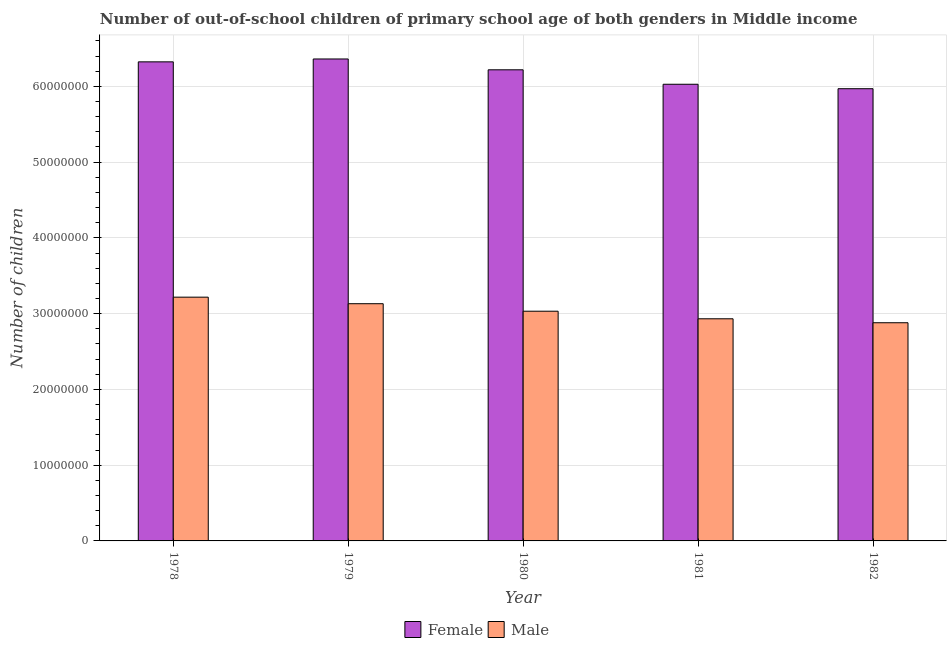How many groups of bars are there?
Your response must be concise. 5. Are the number of bars on each tick of the X-axis equal?
Your answer should be compact. Yes. How many bars are there on the 2nd tick from the left?
Make the answer very short. 2. How many bars are there on the 4th tick from the right?
Make the answer very short. 2. What is the label of the 3rd group of bars from the left?
Your answer should be very brief. 1980. What is the number of male out-of-school students in 1979?
Provide a succinct answer. 3.13e+07. Across all years, what is the maximum number of male out-of-school students?
Ensure brevity in your answer.  3.22e+07. Across all years, what is the minimum number of female out-of-school students?
Provide a succinct answer. 5.97e+07. In which year was the number of male out-of-school students maximum?
Ensure brevity in your answer.  1978. In which year was the number of female out-of-school students minimum?
Make the answer very short. 1982. What is the total number of female out-of-school students in the graph?
Provide a succinct answer. 3.09e+08. What is the difference between the number of female out-of-school students in 1979 and that in 1981?
Your answer should be compact. 3.34e+06. What is the difference between the number of male out-of-school students in 1982 and the number of female out-of-school students in 1979?
Your response must be concise. -2.51e+06. What is the average number of female out-of-school students per year?
Provide a succinct answer. 6.18e+07. In how many years, is the number of female out-of-school students greater than 34000000?
Provide a short and direct response. 5. What is the ratio of the number of female out-of-school students in 1979 to that in 1981?
Your answer should be very brief. 1.06. Is the number of male out-of-school students in 1981 less than that in 1982?
Ensure brevity in your answer.  No. Is the difference between the number of female out-of-school students in 1978 and 1982 greater than the difference between the number of male out-of-school students in 1978 and 1982?
Your response must be concise. No. What is the difference between the highest and the second highest number of female out-of-school students?
Provide a succinct answer. 3.79e+05. What is the difference between the highest and the lowest number of male out-of-school students?
Your answer should be very brief. 3.38e+06. In how many years, is the number of male out-of-school students greater than the average number of male out-of-school students taken over all years?
Ensure brevity in your answer.  2. What does the 2nd bar from the left in 1981 represents?
Keep it short and to the point. Male. What does the 2nd bar from the right in 1978 represents?
Offer a terse response. Female. How many years are there in the graph?
Your response must be concise. 5. What is the difference between two consecutive major ticks on the Y-axis?
Make the answer very short. 1.00e+07. Are the values on the major ticks of Y-axis written in scientific E-notation?
Offer a terse response. No. Does the graph contain any zero values?
Make the answer very short. No. How many legend labels are there?
Your response must be concise. 2. What is the title of the graph?
Your answer should be compact. Number of out-of-school children of primary school age of both genders in Middle income. Does "Unregistered firms" appear as one of the legend labels in the graph?
Give a very brief answer. No. What is the label or title of the X-axis?
Provide a short and direct response. Year. What is the label or title of the Y-axis?
Your response must be concise. Number of children. What is the Number of children in Female in 1978?
Give a very brief answer. 6.32e+07. What is the Number of children in Male in 1978?
Give a very brief answer. 3.22e+07. What is the Number of children in Female in 1979?
Your response must be concise. 6.36e+07. What is the Number of children in Male in 1979?
Offer a very short reply. 3.13e+07. What is the Number of children of Female in 1980?
Ensure brevity in your answer.  6.22e+07. What is the Number of children of Male in 1980?
Keep it short and to the point. 3.03e+07. What is the Number of children of Female in 1981?
Ensure brevity in your answer.  6.03e+07. What is the Number of children of Male in 1981?
Provide a short and direct response. 2.93e+07. What is the Number of children in Female in 1982?
Provide a short and direct response. 5.97e+07. What is the Number of children of Male in 1982?
Offer a terse response. 2.88e+07. Across all years, what is the maximum Number of children in Female?
Offer a terse response. 6.36e+07. Across all years, what is the maximum Number of children in Male?
Give a very brief answer. 3.22e+07. Across all years, what is the minimum Number of children in Female?
Your answer should be very brief. 5.97e+07. Across all years, what is the minimum Number of children of Male?
Keep it short and to the point. 2.88e+07. What is the total Number of children in Female in the graph?
Your answer should be compact. 3.09e+08. What is the total Number of children of Male in the graph?
Provide a succinct answer. 1.52e+08. What is the difference between the Number of children in Female in 1978 and that in 1979?
Make the answer very short. -3.79e+05. What is the difference between the Number of children in Male in 1978 and that in 1979?
Your response must be concise. 8.65e+05. What is the difference between the Number of children in Female in 1978 and that in 1980?
Offer a very short reply. 1.05e+06. What is the difference between the Number of children in Male in 1978 and that in 1980?
Your answer should be very brief. 1.85e+06. What is the difference between the Number of children of Female in 1978 and that in 1981?
Your answer should be very brief. 2.96e+06. What is the difference between the Number of children of Male in 1978 and that in 1981?
Offer a terse response. 2.85e+06. What is the difference between the Number of children in Female in 1978 and that in 1982?
Your answer should be very brief. 3.55e+06. What is the difference between the Number of children in Male in 1978 and that in 1982?
Your answer should be very brief. 3.38e+06. What is the difference between the Number of children of Female in 1979 and that in 1980?
Offer a terse response. 1.43e+06. What is the difference between the Number of children of Male in 1979 and that in 1980?
Provide a short and direct response. 9.89e+05. What is the difference between the Number of children of Female in 1979 and that in 1981?
Ensure brevity in your answer.  3.34e+06. What is the difference between the Number of children in Male in 1979 and that in 1981?
Your answer should be compact. 1.99e+06. What is the difference between the Number of children of Female in 1979 and that in 1982?
Make the answer very short. 3.92e+06. What is the difference between the Number of children in Male in 1979 and that in 1982?
Offer a terse response. 2.51e+06. What is the difference between the Number of children of Female in 1980 and that in 1981?
Give a very brief answer. 1.91e+06. What is the difference between the Number of children of Male in 1980 and that in 1981?
Your answer should be very brief. 1.00e+06. What is the difference between the Number of children of Female in 1980 and that in 1982?
Keep it short and to the point. 2.49e+06. What is the difference between the Number of children in Male in 1980 and that in 1982?
Offer a very short reply. 1.52e+06. What is the difference between the Number of children in Female in 1981 and that in 1982?
Your response must be concise. 5.88e+05. What is the difference between the Number of children of Male in 1981 and that in 1982?
Ensure brevity in your answer.  5.22e+05. What is the difference between the Number of children in Female in 1978 and the Number of children in Male in 1979?
Provide a short and direct response. 3.19e+07. What is the difference between the Number of children of Female in 1978 and the Number of children of Male in 1980?
Ensure brevity in your answer.  3.29e+07. What is the difference between the Number of children of Female in 1978 and the Number of children of Male in 1981?
Your answer should be compact. 3.39e+07. What is the difference between the Number of children in Female in 1978 and the Number of children in Male in 1982?
Your answer should be compact. 3.44e+07. What is the difference between the Number of children in Female in 1979 and the Number of children in Male in 1980?
Your answer should be very brief. 3.33e+07. What is the difference between the Number of children in Female in 1979 and the Number of children in Male in 1981?
Your answer should be very brief. 3.43e+07. What is the difference between the Number of children of Female in 1979 and the Number of children of Male in 1982?
Offer a terse response. 3.48e+07. What is the difference between the Number of children in Female in 1980 and the Number of children in Male in 1981?
Ensure brevity in your answer.  3.29e+07. What is the difference between the Number of children in Female in 1980 and the Number of children in Male in 1982?
Your response must be concise. 3.34e+07. What is the difference between the Number of children of Female in 1981 and the Number of children of Male in 1982?
Provide a short and direct response. 3.15e+07. What is the average Number of children of Female per year?
Offer a terse response. 6.18e+07. What is the average Number of children in Male per year?
Offer a very short reply. 3.04e+07. In the year 1978, what is the difference between the Number of children of Female and Number of children of Male?
Offer a very short reply. 3.11e+07. In the year 1979, what is the difference between the Number of children in Female and Number of children in Male?
Provide a short and direct response. 3.23e+07. In the year 1980, what is the difference between the Number of children of Female and Number of children of Male?
Your response must be concise. 3.19e+07. In the year 1981, what is the difference between the Number of children of Female and Number of children of Male?
Offer a terse response. 3.10e+07. In the year 1982, what is the difference between the Number of children in Female and Number of children in Male?
Your answer should be compact. 3.09e+07. What is the ratio of the Number of children in Male in 1978 to that in 1979?
Ensure brevity in your answer.  1.03. What is the ratio of the Number of children of Female in 1978 to that in 1980?
Keep it short and to the point. 1.02. What is the ratio of the Number of children in Male in 1978 to that in 1980?
Give a very brief answer. 1.06. What is the ratio of the Number of children of Female in 1978 to that in 1981?
Your answer should be compact. 1.05. What is the ratio of the Number of children of Male in 1978 to that in 1981?
Your answer should be very brief. 1.1. What is the ratio of the Number of children in Female in 1978 to that in 1982?
Give a very brief answer. 1.06. What is the ratio of the Number of children of Male in 1978 to that in 1982?
Give a very brief answer. 1.12. What is the ratio of the Number of children in Female in 1979 to that in 1980?
Offer a very short reply. 1.02. What is the ratio of the Number of children in Male in 1979 to that in 1980?
Ensure brevity in your answer.  1.03. What is the ratio of the Number of children in Female in 1979 to that in 1981?
Your answer should be compact. 1.06. What is the ratio of the Number of children of Male in 1979 to that in 1981?
Provide a short and direct response. 1.07. What is the ratio of the Number of children of Female in 1979 to that in 1982?
Ensure brevity in your answer.  1.07. What is the ratio of the Number of children in Male in 1979 to that in 1982?
Keep it short and to the point. 1.09. What is the ratio of the Number of children of Female in 1980 to that in 1981?
Your answer should be very brief. 1.03. What is the ratio of the Number of children of Male in 1980 to that in 1981?
Your answer should be compact. 1.03. What is the ratio of the Number of children in Female in 1980 to that in 1982?
Provide a short and direct response. 1.04. What is the ratio of the Number of children in Male in 1980 to that in 1982?
Your response must be concise. 1.05. What is the ratio of the Number of children of Female in 1981 to that in 1982?
Offer a terse response. 1.01. What is the ratio of the Number of children in Male in 1981 to that in 1982?
Make the answer very short. 1.02. What is the difference between the highest and the second highest Number of children of Female?
Your answer should be very brief. 3.79e+05. What is the difference between the highest and the second highest Number of children of Male?
Give a very brief answer. 8.65e+05. What is the difference between the highest and the lowest Number of children of Female?
Your answer should be compact. 3.92e+06. What is the difference between the highest and the lowest Number of children in Male?
Offer a terse response. 3.38e+06. 